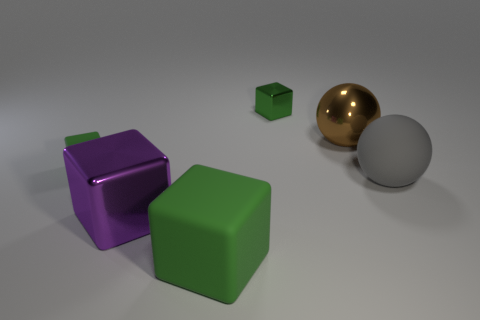Is the small matte thing the same color as the big rubber block?
Provide a short and direct response. Yes. How many small yellow rubber cylinders are there?
Your answer should be compact. 0. There is a sphere in front of the small thing in front of the tiny green thing on the right side of the purple object; what is its material?
Offer a very short reply. Rubber. How many metal balls are on the left side of the metallic thing that is in front of the large gray rubber ball?
Your answer should be compact. 0. There is another metallic object that is the same shape as the purple metallic object; what color is it?
Give a very brief answer. Green. Do the large green block and the purple thing have the same material?
Offer a terse response. No. What number of cylinders are tiny green matte things or large purple shiny things?
Keep it short and to the point. 0. There is a green object that is on the left side of the shiny object in front of the large ball behind the gray object; what size is it?
Make the answer very short. Small. There is a green metal object that is the same shape as the small matte thing; what size is it?
Your answer should be compact. Small. How many small green things are behind the large brown thing?
Your answer should be compact. 1. 